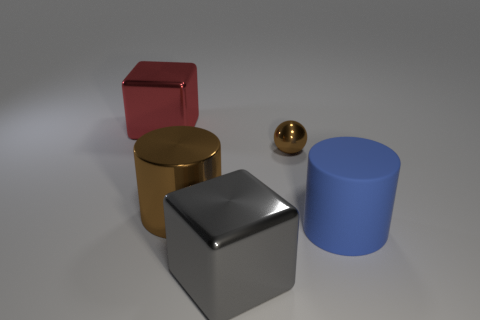Subtract all red cylinders. Subtract all yellow balls. How many cylinders are left? 2 Add 5 big brown metal objects. How many objects exist? 10 Subtract all cylinders. How many objects are left? 3 Subtract 0 cyan blocks. How many objects are left? 5 Subtract all metallic cubes. Subtract all big gray things. How many objects are left? 2 Add 1 red metal things. How many red metal things are left? 2 Add 4 big blue objects. How many big blue objects exist? 5 